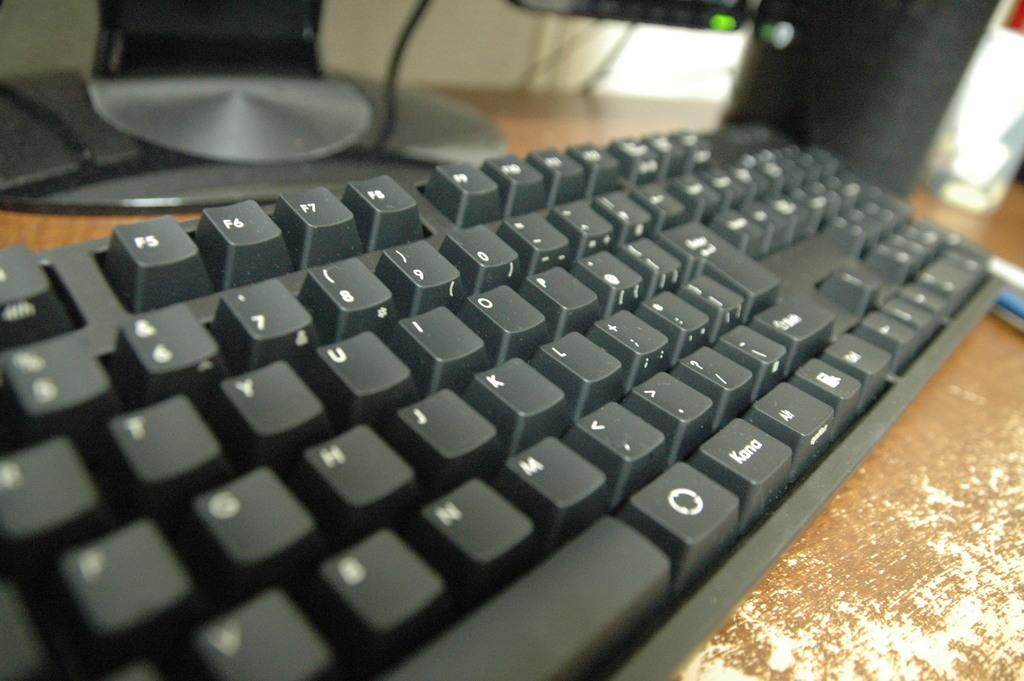Provide a one-sentence caption for the provided image. A side angle picture of a keyboard with the word "kana" on it. 